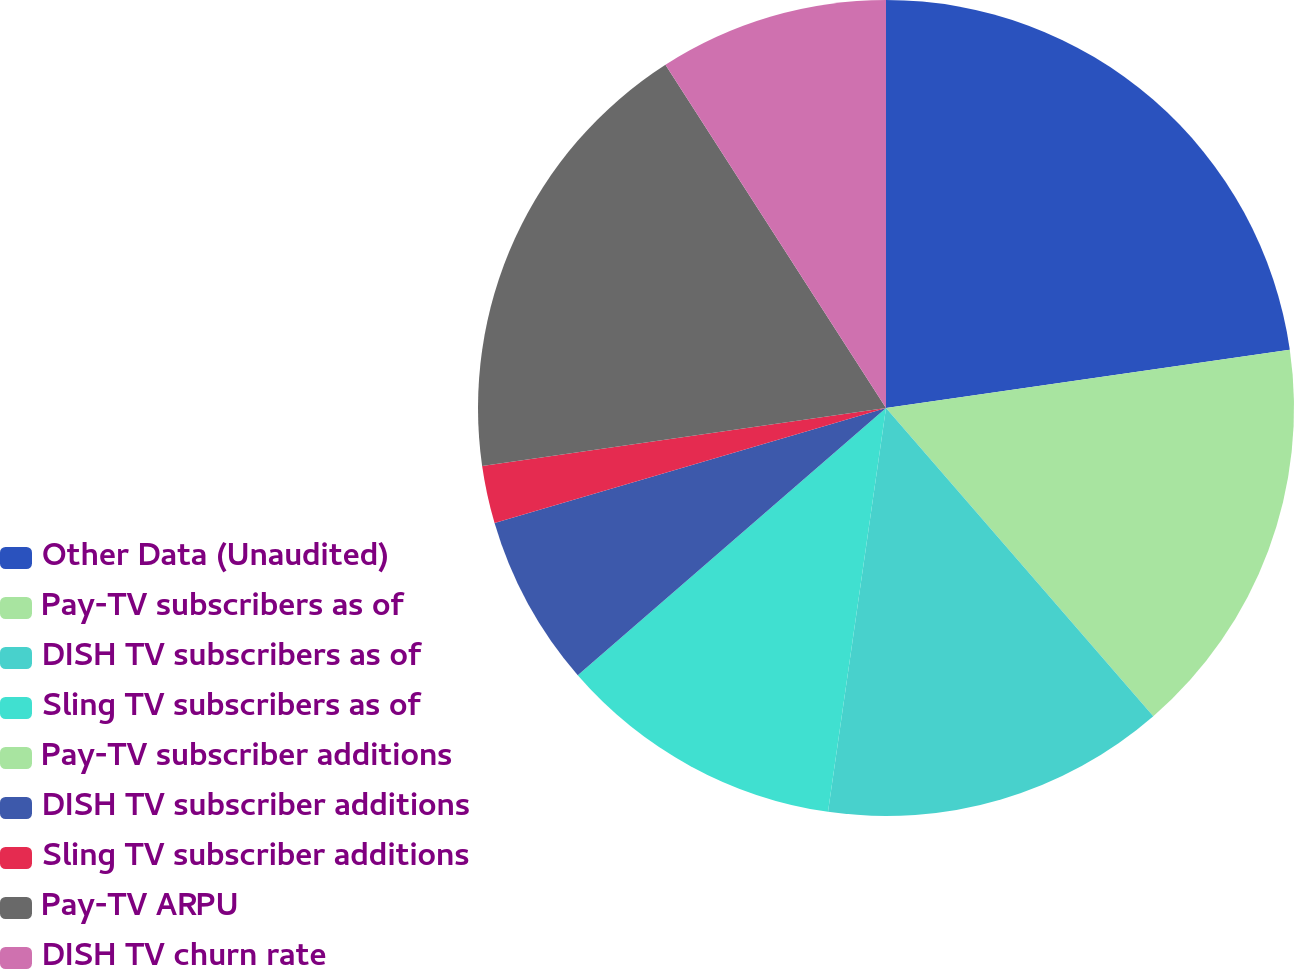Convert chart. <chart><loc_0><loc_0><loc_500><loc_500><pie_chart><fcel>Other Data (Unaudited)<fcel>Pay-TV subscribers as of<fcel>DISH TV subscribers as of<fcel>Sling TV subscribers as of<fcel>Pay-TV subscriber additions<fcel>DISH TV subscriber additions<fcel>Sling TV subscriber additions<fcel>Pay-TV ARPU<fcel>DISH TV churn rate<nl><fcel>22.72%<fcel>15.91%<fcel>13.64%<fcel>11.36%<fcel>0.0%<fcel>6.82%<fcel>2.28%<fcel>18.18%<fcel>9.09%<nl></chart> 